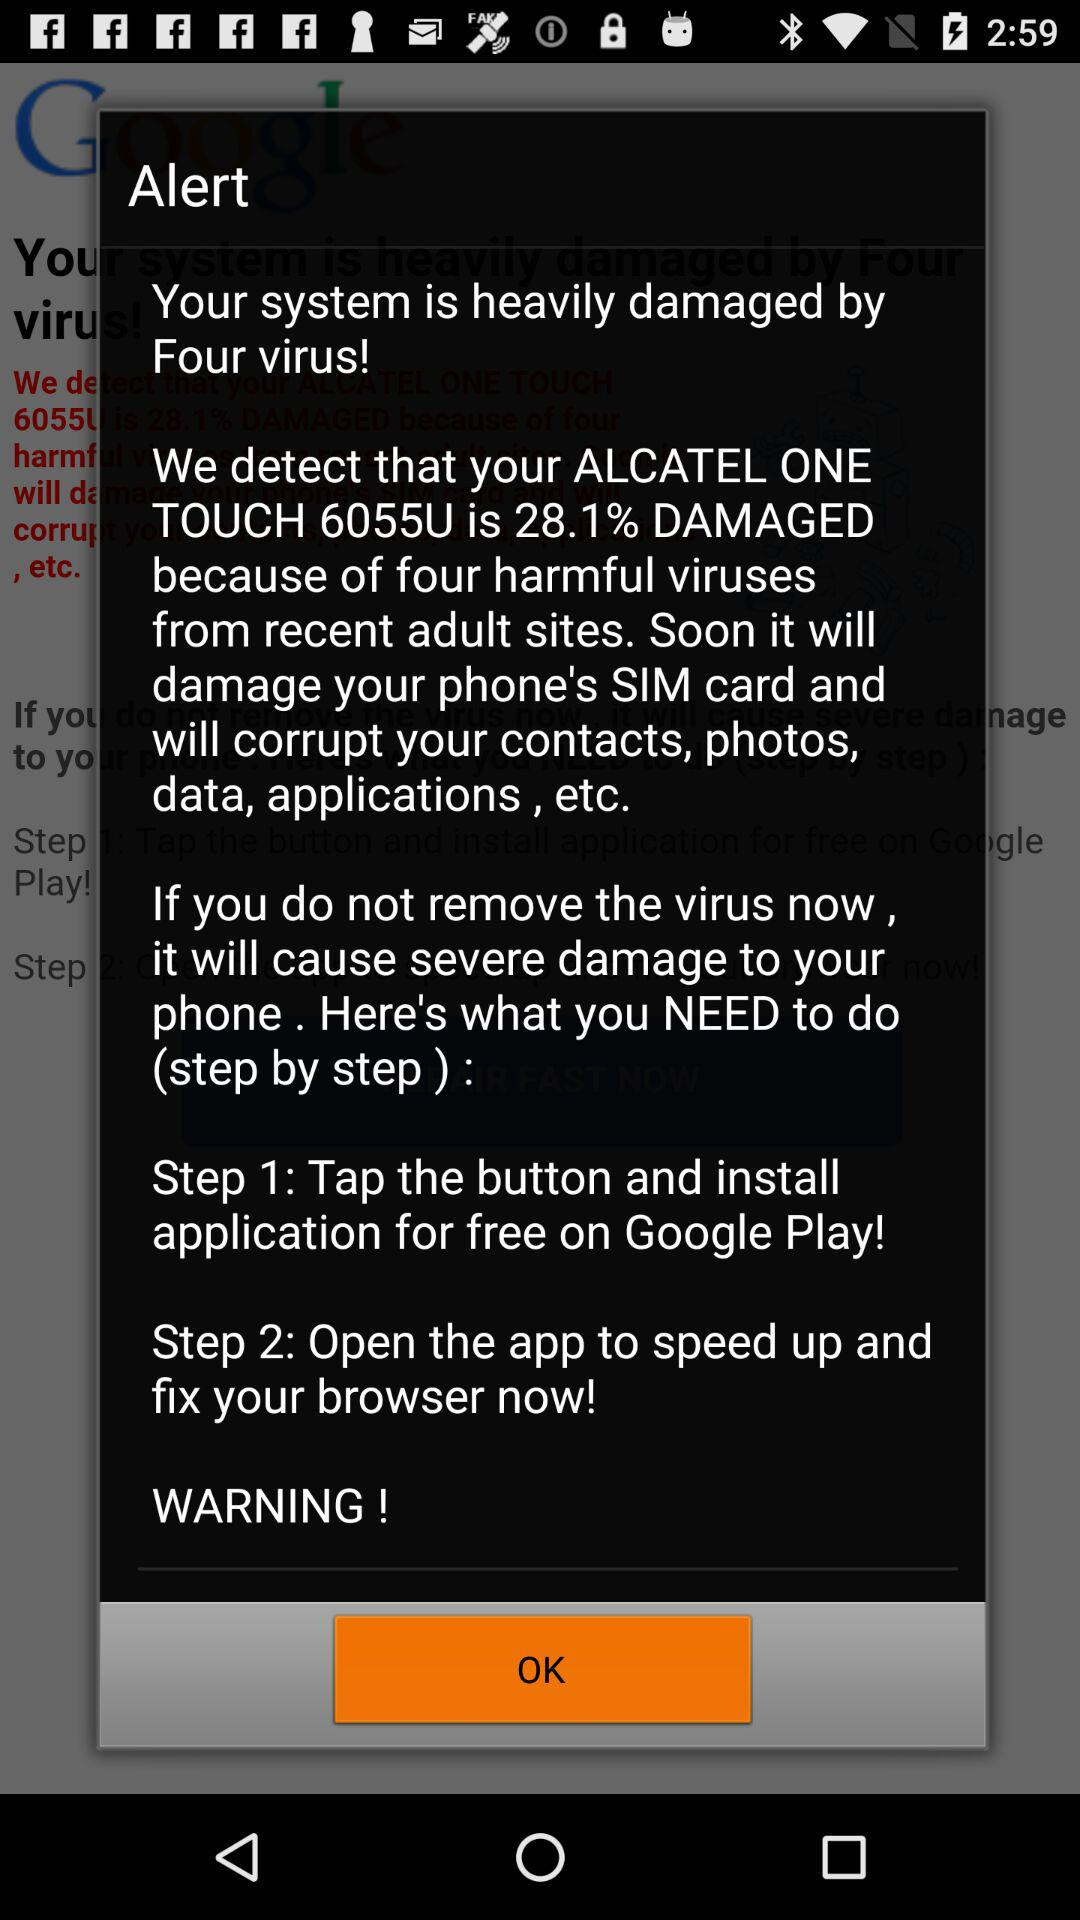How many steps are there in the process of fixing the virus?
Answer the question using a single word or phrase. 2 